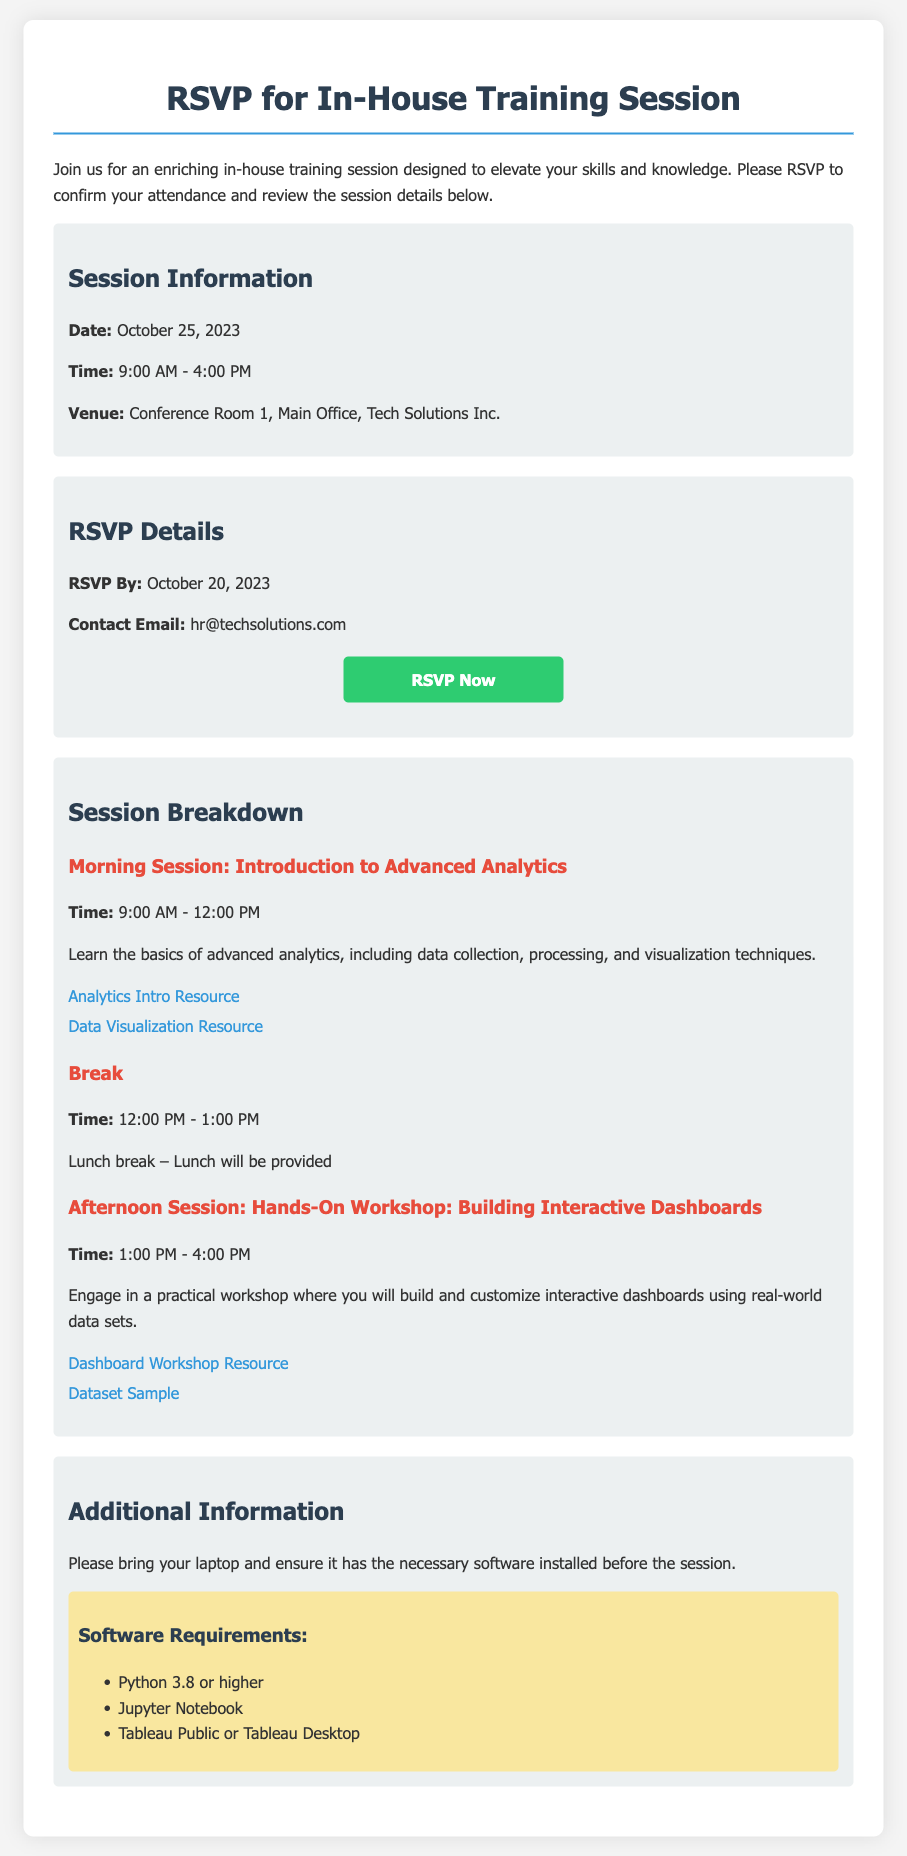What is the date of the training session? The date of the training session is explicitly stated in the session information section of the document.
Answer: October 25, 2023 What time does the morning session start? The start time for the morning session is mentioned in the session breakdown section of the document.
Answer: 9:00 AM How long is the lunch break? The duration of the lunch break can be inferred from the schedule provided in the session breakdown.
Answer: 1 hour What is the venue for the training session? The venue is detailed in the session information portion of the RSVP document.
Answer: Conference Room 1, Main Office, Tech Solutions Inc When is the RSVP deadline? The RSVP deadline is specified in the RSVP details of the document.
Answer: October 20, 2023 What is one of the software requirements for the training session? The software requirements are listed under additional information, providing specific software needed for the session.
Answer: Python 3.8 or higher What type of training activity is planned for the afternoon session? The type of training activity for the afternoon session is described in the session breakdown, indicating the nature of the workshop.
Answer: Hands-On Workshop: Building Interactive Dashboards What will be provided during the lunch break? The document states what will be provided for lunch during the break for the training session.
Answer: Lunch will be provided What must participants bring to the training session? The additional information section mentions what participants should bring to the session for optimal participation.
Answer: Laptop 